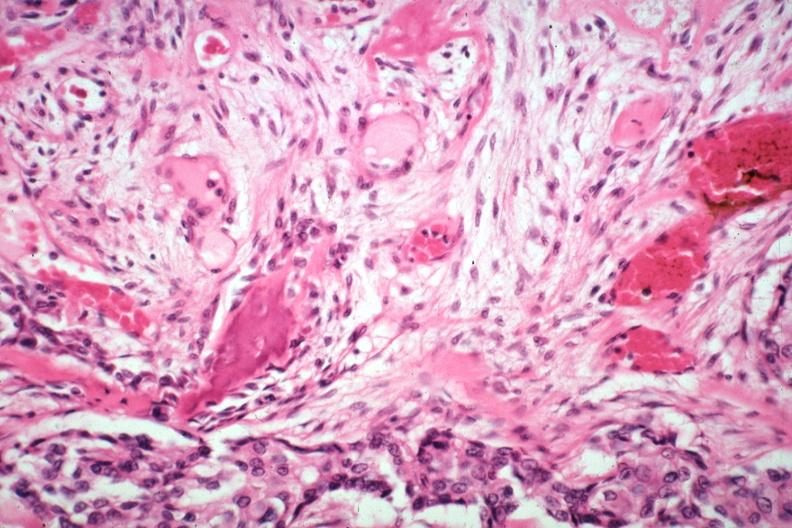what does this image show?
Answer the question using a single word or phrase. New bone formation excellent depiction large myofibroblastic osteoblastic cells induced by tumor tumor also seen gross is additional 3194 and 